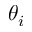<formula> <loc_0><loc_0><loc_500><loc_500>\theta _ { i }</formula> 